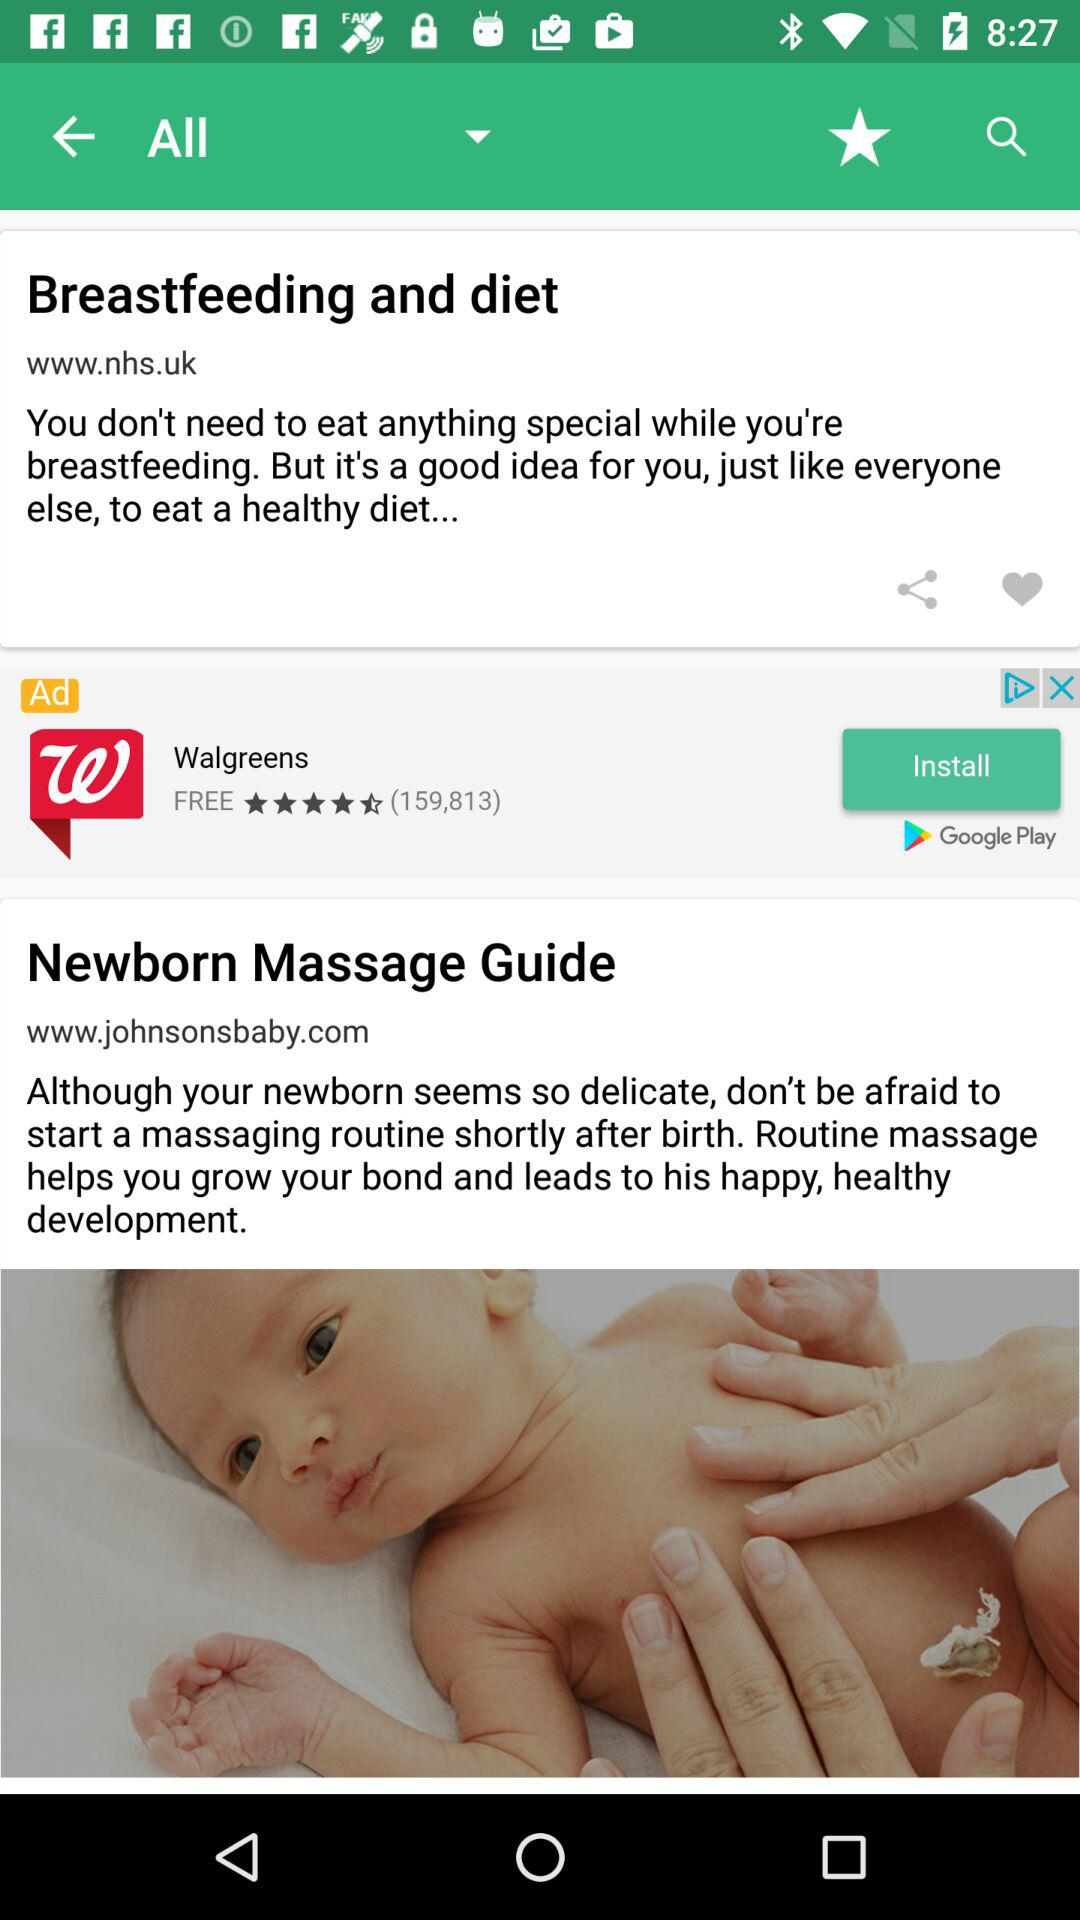What site is given for "Breastfeeding and diet"? The given site for "Breastfeeding and diet" is www.nhs.uk. 